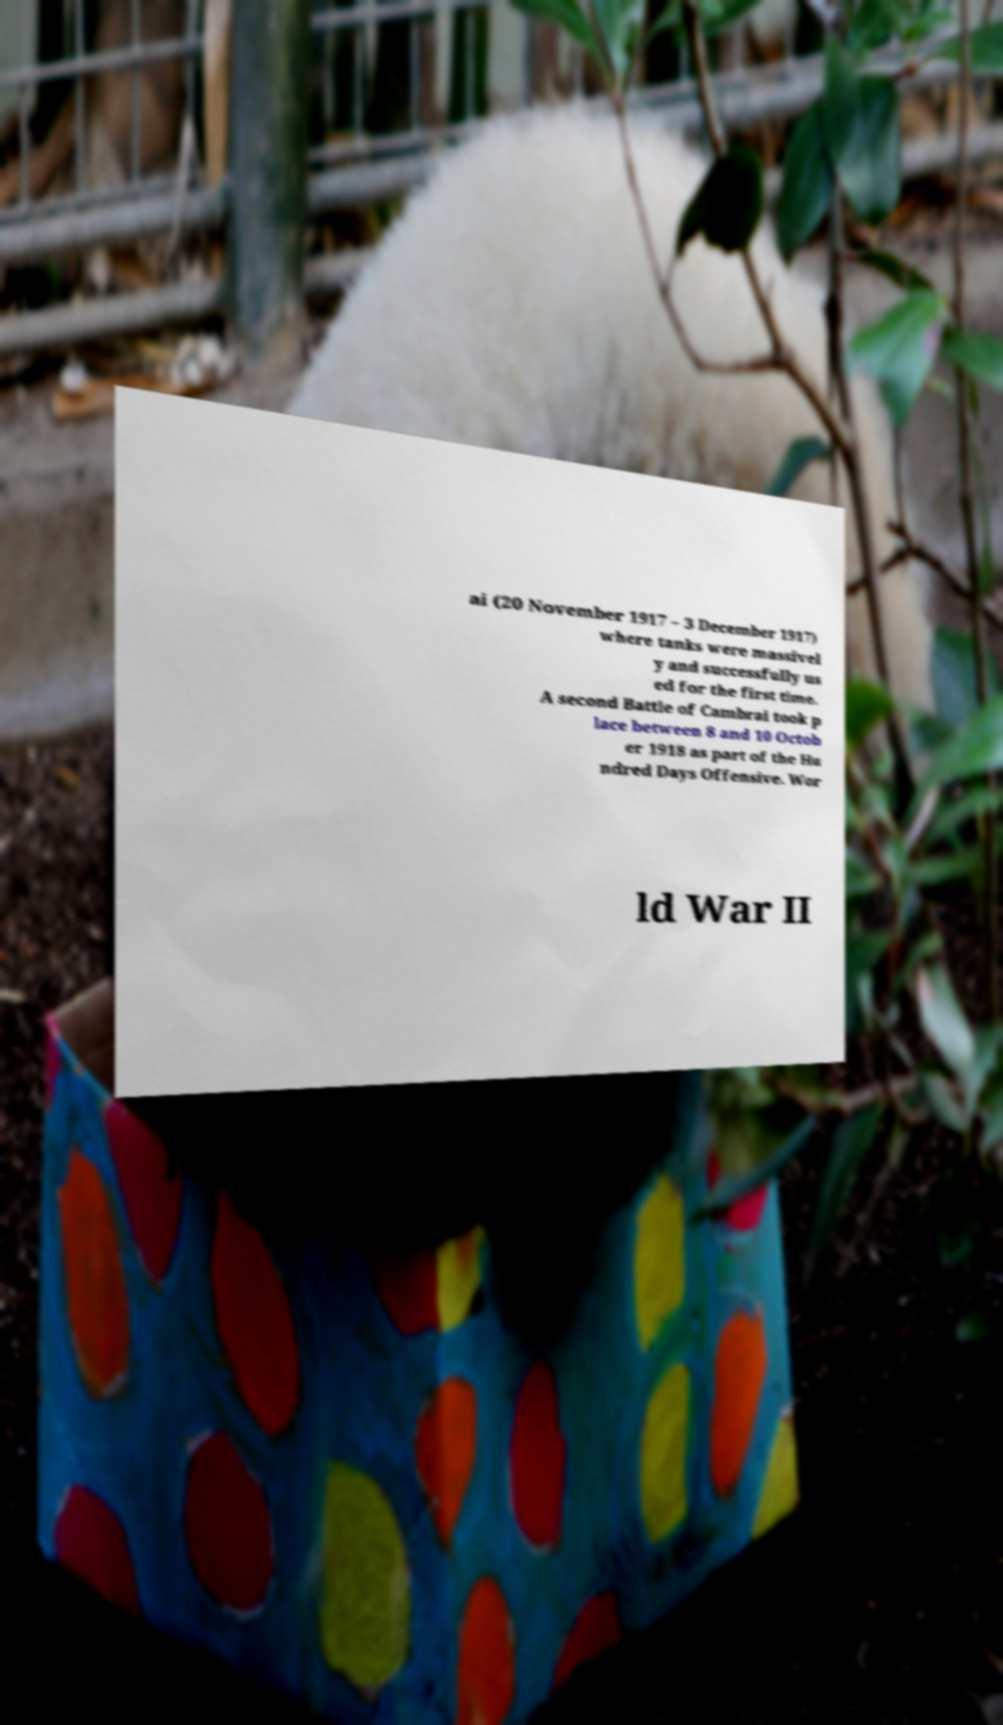Please read and relay the text visible in this image. What does it say? ai (20 November 1917 – 3 December 1917) where tanks were massivel y and successfully us ed for the first time. A second Battle of Cambrai took p lace between 8 and 10 Octob er 1918 as part of the Hu ndred Days Offensive. Wor ld War II 